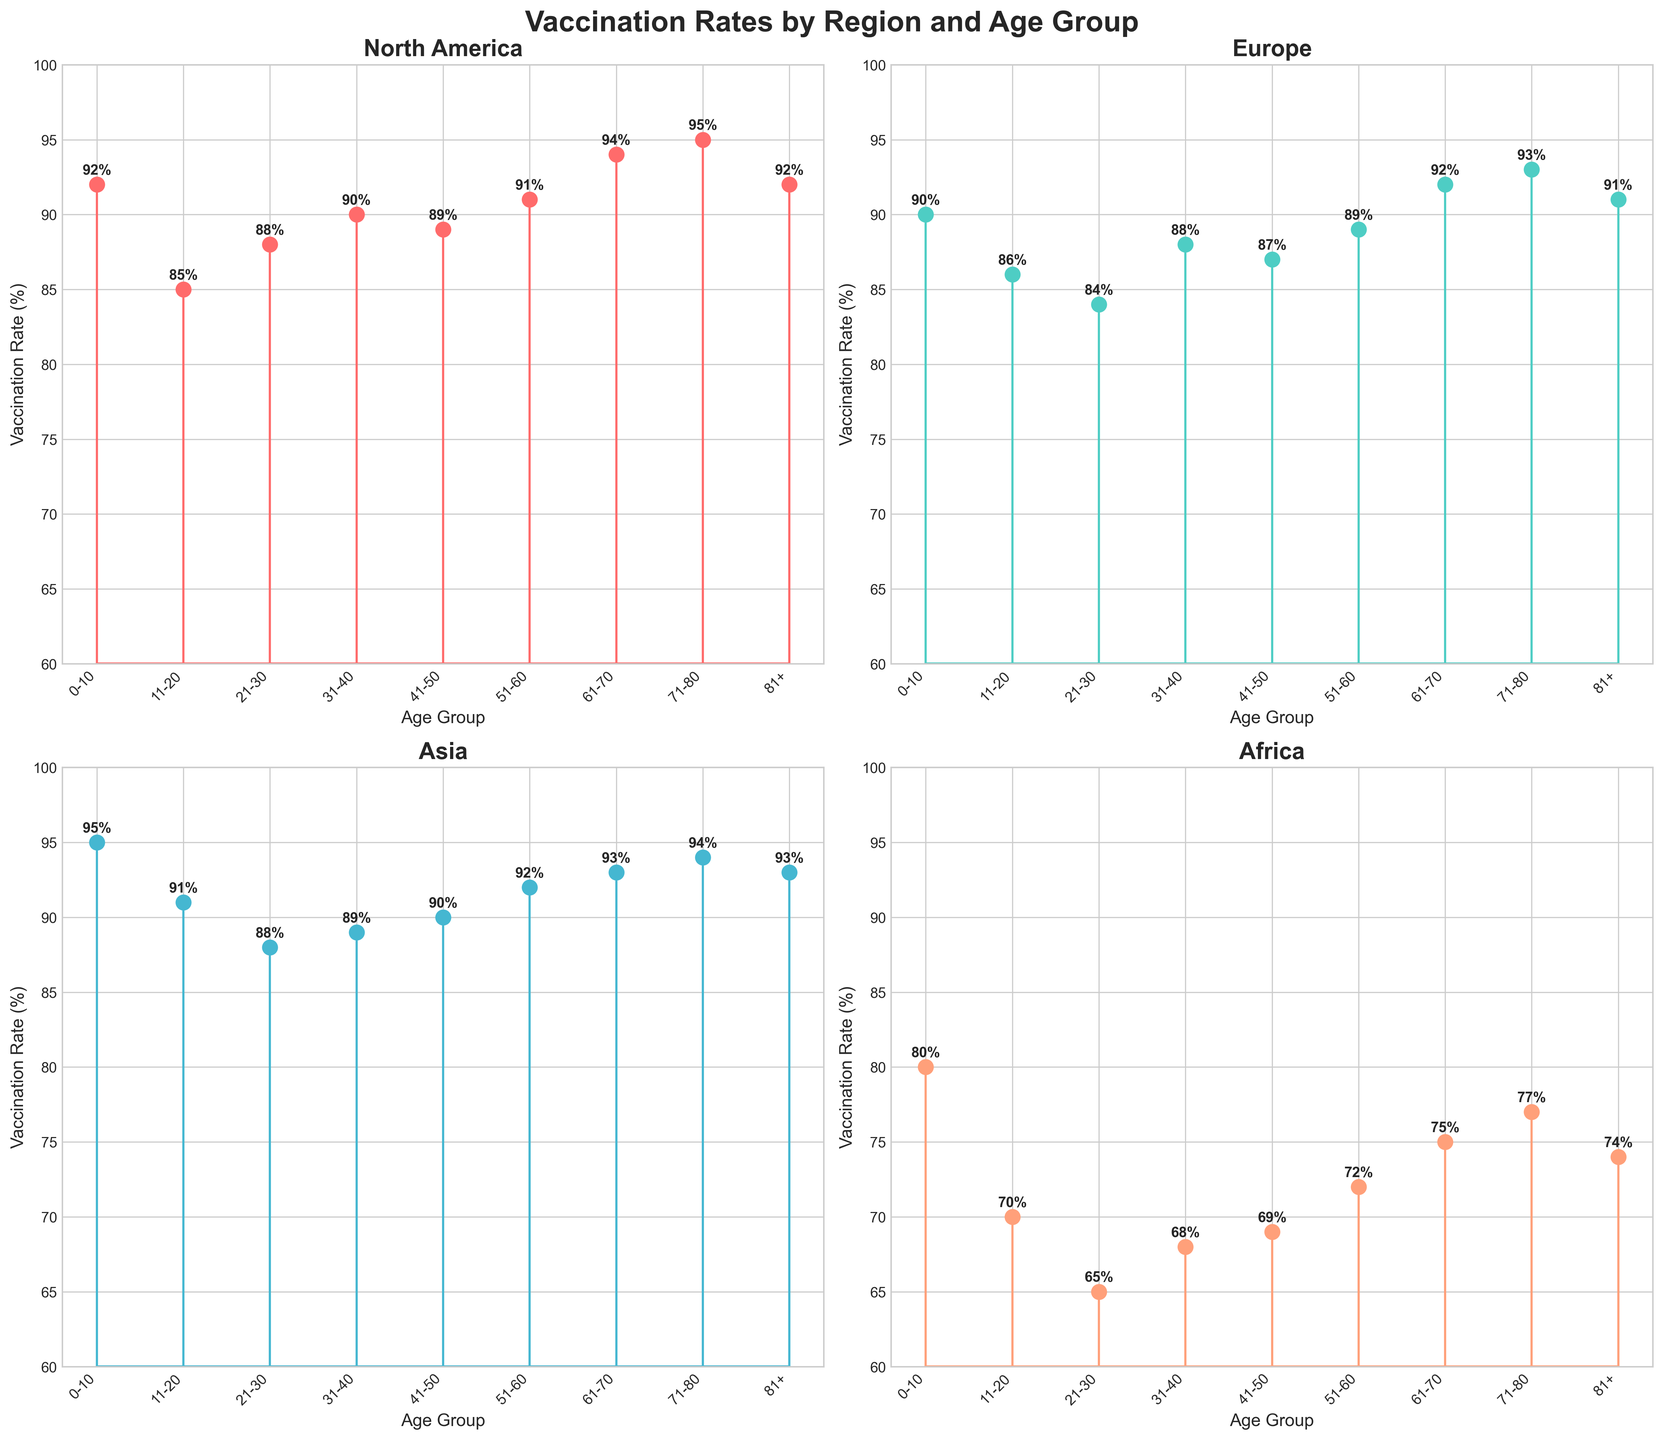What's the title of the figure? The title is at the top center of the figure. It reads "Vaccination Rates by Region and Age Group".
Answer: Vaccination Rates by Region and Age Group Which region shows the lowest vaccination rate for the age group 21-30? In the subplot for each region, find the age group labeled 21-30 along the x-axis and look for the stem height. Africa has the lowest point at this age group.
Answer: Africa What is the range of vaccination rates in Europe? Look at the highest and lowest points of the stems in the Europe subplot. The highest rate is 93% for the age group 71-80, and the lowest is 84% for the age group 21-30. Subtract these values to get the range 93 - 84 = 9.
Answer: 9 Which region has the highest average vaccination rate? Calculate the average vaccination rate for each region by summing the values of all age groups for that region and dividing by the number of age groups. Compare these averages to determine the highest. North America (91.78), Europe (88.88), Asia (91.67), Africa (72.22). North America has the highest average rate.
Answer: North America Are there any age groups where the vaccination rates are equal across all regions? Compare the heights of the stems for each age group across all regional plots. None of the age groups have equal vaccination rates across all regions.
Answer: No What is the vaccination rate of the 81+ age group in Asia? Locate the subplot for Asia and find the stem corresponding to the 81+ age group. The stem height shows a vaccination rate of 93%.
Answer: 93% Which age group has the most significant difference in vaccination rates between North America and Africa? Look at the difference in stem heights between North America and Africa for each age group. The 0-10 age group has the largest difference: North America (92%) - Africa (80%) = 12.
Answer: 0-10 In which region is the vaccination rate for the 0-10 age group the highest? Compare the stems for the 0-10 age group across all regional subplots. Asia has the highest rate at 95%.
Answer: Asia How does the vaccination rate for the age group 51-60 in North America compare to that in Europe? Compare the stem heights for the age group 51-60 in the plots for North America and Europe. North America's rate is 91% while Europe's rate is 89%. North America's rate is higher by 2%.
Answer: Higher by 2% 